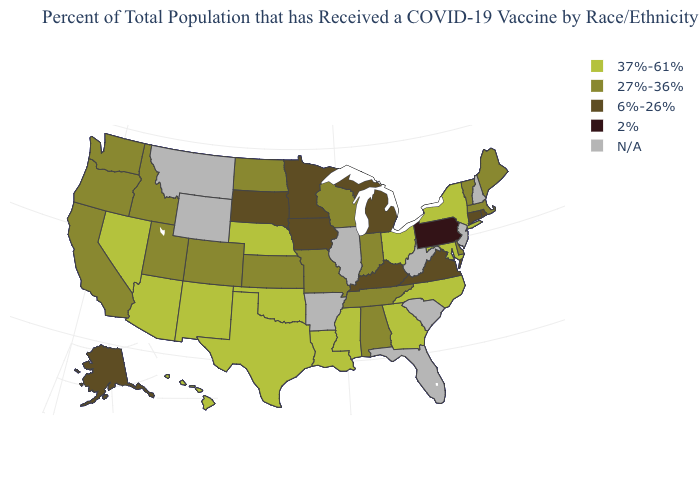What is the value of Ohio?
Give a very brief answer. 37%-61%. What is the value of South Dakota?
Answer briefly. 6%-26%. What is the highest value in the West ?
Answer briefly. 37%-61%. What is the value of Maine?
Short answer required. 27%-36%. What is the lowest value in states that border Missouri?
Short answer required. 6%-26%. What is the value of New Jersey?
Quick response, please. N/A. Does the map have missing data?
Quick response, please. Yes. What is the lowest value in states that border Michigan?
Concise answer only. 27%-36%. Which states have the lowest value in the Northeast?
Answer briefly. Pennsylvania. What is the highest value in the South ?
Quick response, please. 37%-61%. What is the value of Iowa?
Quick response, please. 6%-26%. What is the value of Nevada?
Quick response, please. 37%-61%. What is the lowest value in the Northeast?
Be succinct. 2%. What is the value of Iowa?
Answer briefly. 6%-26%. 